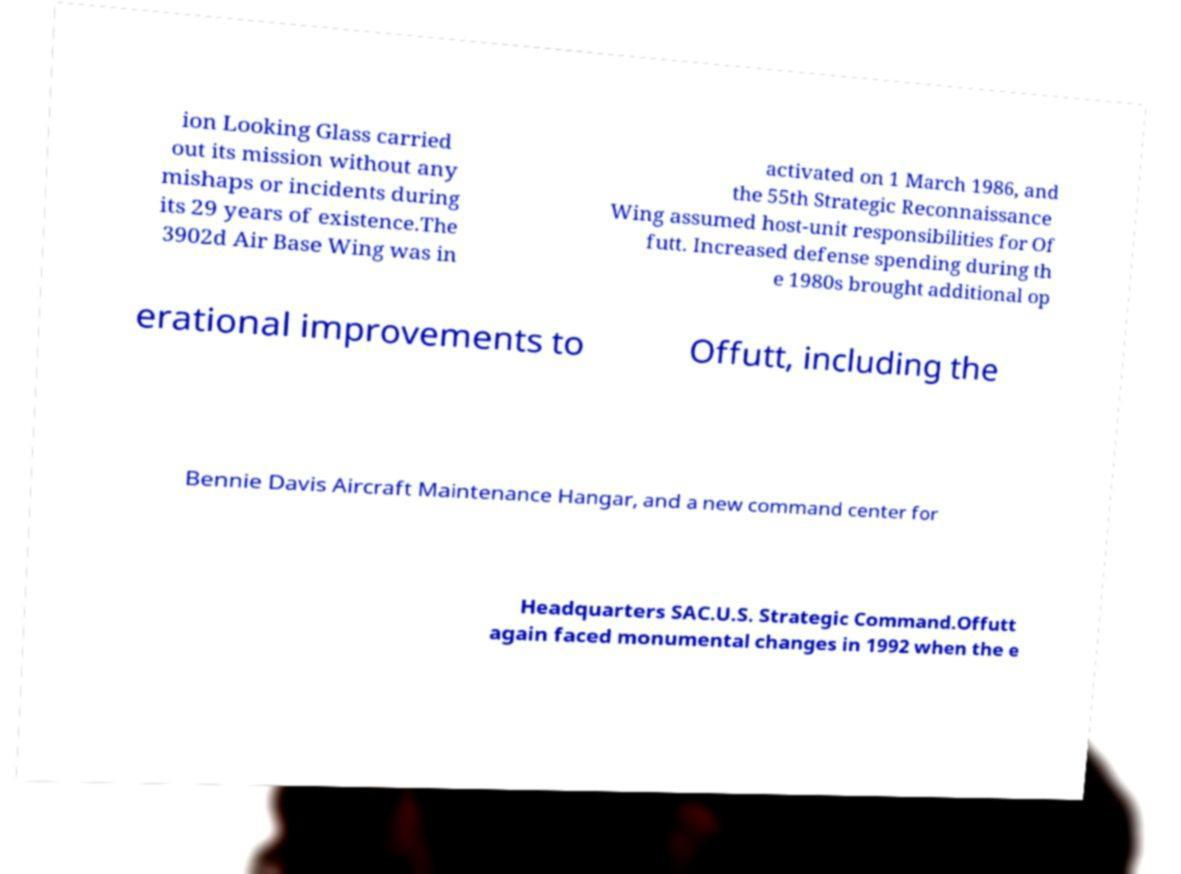Please read and relay the text visible in this image. What does it say? ion Looking Glass carried out its mission without any mishaps or incidents during its 29 years of existence.The 3902d Air Base Wing was in activated on 1 March 1986, and the 55th Strategic Reconnaissance Wing assumed host-unit responsibilities for Of futt. Increased defense spending during th e 1980s brought additional op erational improvements to Offutt, including the Bennie Davis Aircraft Maintenance Hangar, and a new command center for Headquarters SAC.U.S. Strategic Command.Offutt again faced monumental changes in 1992 when the e 